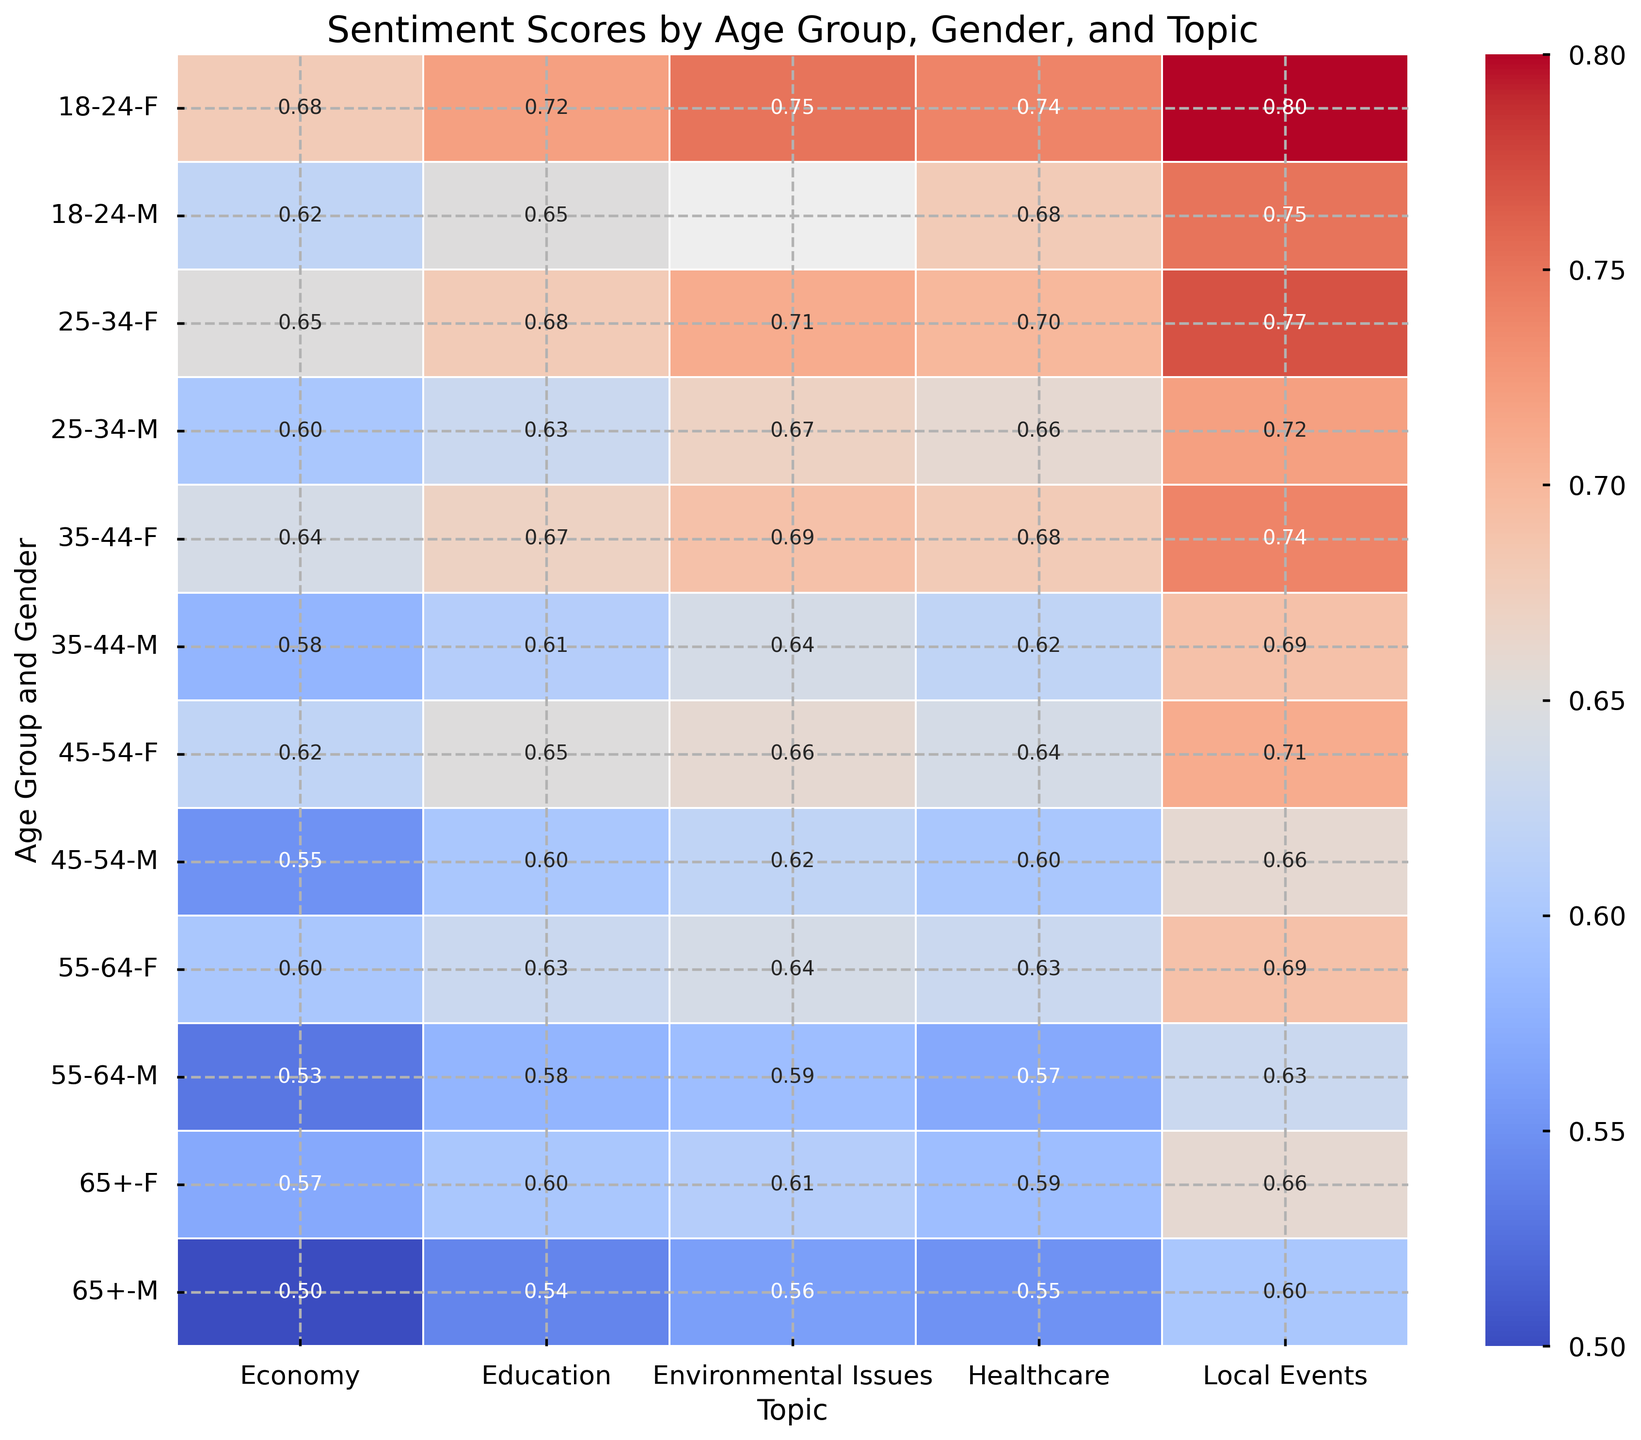Which age group and gender has the highest sentiment score for Local Events? To find the answer, locate the "Local Events" column in the heatmap, then look for the highest sentiment score across all age groups and genders
Answer: 18-24, F Who has a higher sentiment score for Healthcare, women aged 35-44 or men aged 45-54? Compare the sentiment scores in the "Healthcare" column for women aged 35-44 and men aged 45-54. Women aged 35-44 have a score of 0.68, while men aged 45-54 have a score of 0.60
Answer: Women aged 35-44 What is the average sentiment score for Local Events for the 25-34 age group? The sentiment score for Local Events in the 25-34 age group is 0.72 for men and 0.77 for women. The average is calculated: (0.72 + 0.77) / 2 = 0.745
Answer: 0.745 Do men or women aged 55-64 have a higher sentiment score for Environmental Issues? Compare the sentiment scores in the "Environmental Issues" column for men and women aged 55-64. Men have a score of 0.59, and women have a score of 0.64
Answer: Women Which topic has the lowest sentiment score among people aged 65+? Look at the sentiment scores across all topics for the 65+ age group. Identify the lowest score, which is 0.50 for the topic "Economy"
Answer: Economy What is the difference in sentiment scores for Education between men aged 18-24 and men aged 65+? Find the sentiment scores in the "Education" column for men aged 18-24 and men aged 65+. The scores are 0.65 and 0.54, respectively. The difference is calculated: 0.65 - 0.54 = 0.11
Answer: 0.11 Which gender shows more positive sentiment towards the Economy in the 35-44 age group? Compare the sentiment scores in the "Economy" column for men and women aged 35-44. Women have a score of 0.64, and men have a score of 0.58
Answer: Women Which topic shows the smallest gender difference in sentiment scores for people aged 45-54? Compare the absolute differences in sentiment scores between men and women aged 45-54 for each topic. The smallest difference is found in the "Education" topic with a difference of
Answer: 0.05 